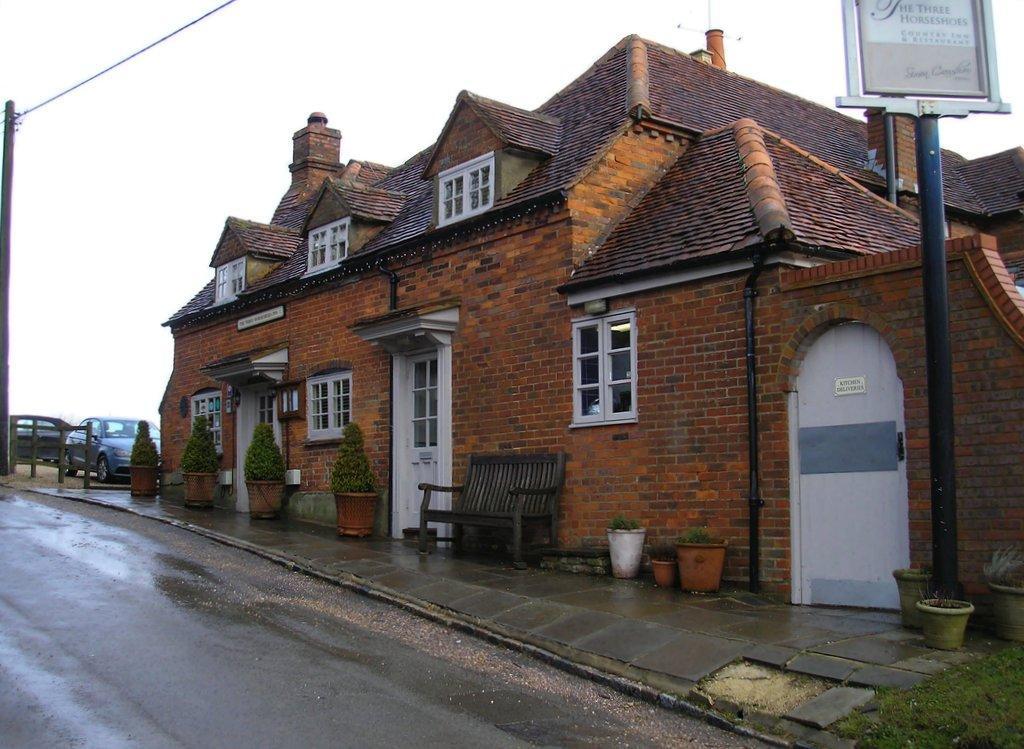In one or two sentences, can you explain what this image depicts? In this image there is the sky, there is a house truncated, there are windows, there are doors, there is a bench, there are flower pots, there are plants, there is a poll, there is a board truncated, there is a pole towards the left of the image, there is a wire, there are vehicles, there is fencing, there is road, there is a flower pot truncated towards the right of the image. 